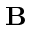Convert formula to latex. <formula><loc_0><loc_0><loc_500><loc_500>\mathbf B</formula> 